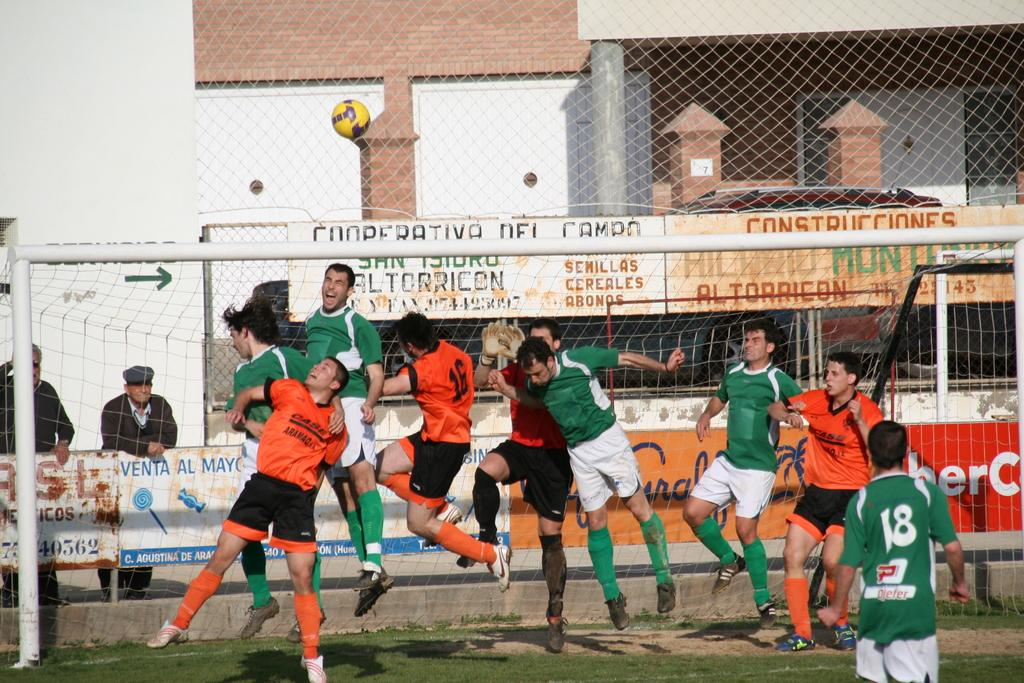<image>
Provide a brief description of the given image. Players crowd the net as number 18 looks on. 